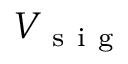<formula> <loc_0><loc_0><loc_500><loc_500>V _ { s i g }</formula> 